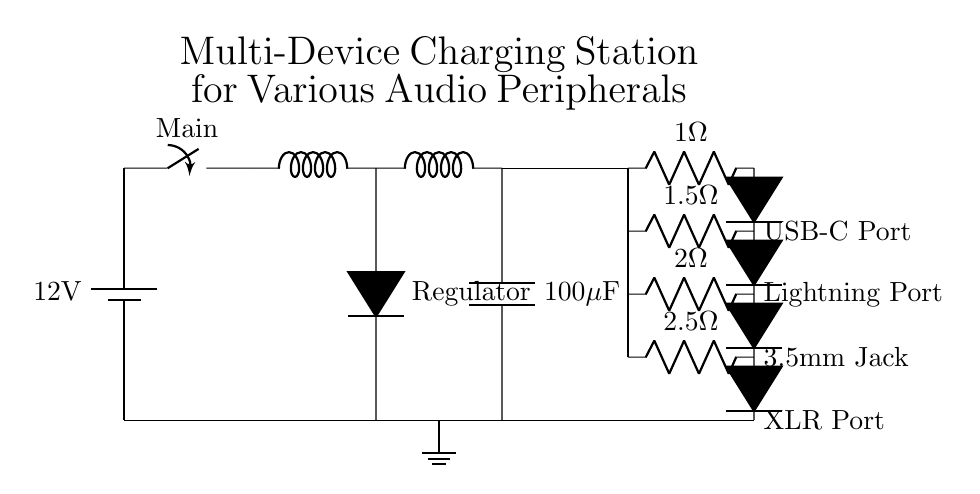What is the voltage of the power source? The power source in the circuit diagram is labeled as a battery providing a voltage of 12 volts.
Answer: 12 volts What type of voltage regulation is used in this circuit? The circuit uses a voltage regulator to maintain a steady output voltage, indicated by the symbol D*.
Answer: Voltage regulator How many charging ports are present in the circuit? The circuit diagram displays four charging ports: USB-C, Lightning, 3.5mm Jack, and XLR Port. Therefore, there are four charging ports in total.
Answer: Four What is the resistance value for the USB-C port? The resistance connected to the USB-C port is labeled as 1 ohm in the circuit diagram.
Answer: 1 ohm What happens to the voltage as it passes through the resistance before reaching the USB-C port? As the voltage passes through the 1 ohm resistance before reaching the USB-C port, it experiences a drop in instantaneous voltage according to Ohm's law. Actual voltage is not given but current can be derived based on voltage and resistance.
Answer: Voltage drop occurs Which component provides filtering in this charging circuit? The component that provides filtering in this circuit is the capacitor, specifically a 100 microfarads capacitor. It smooths out the voltage to prevent fluctuations.
Answer: Capacitor 